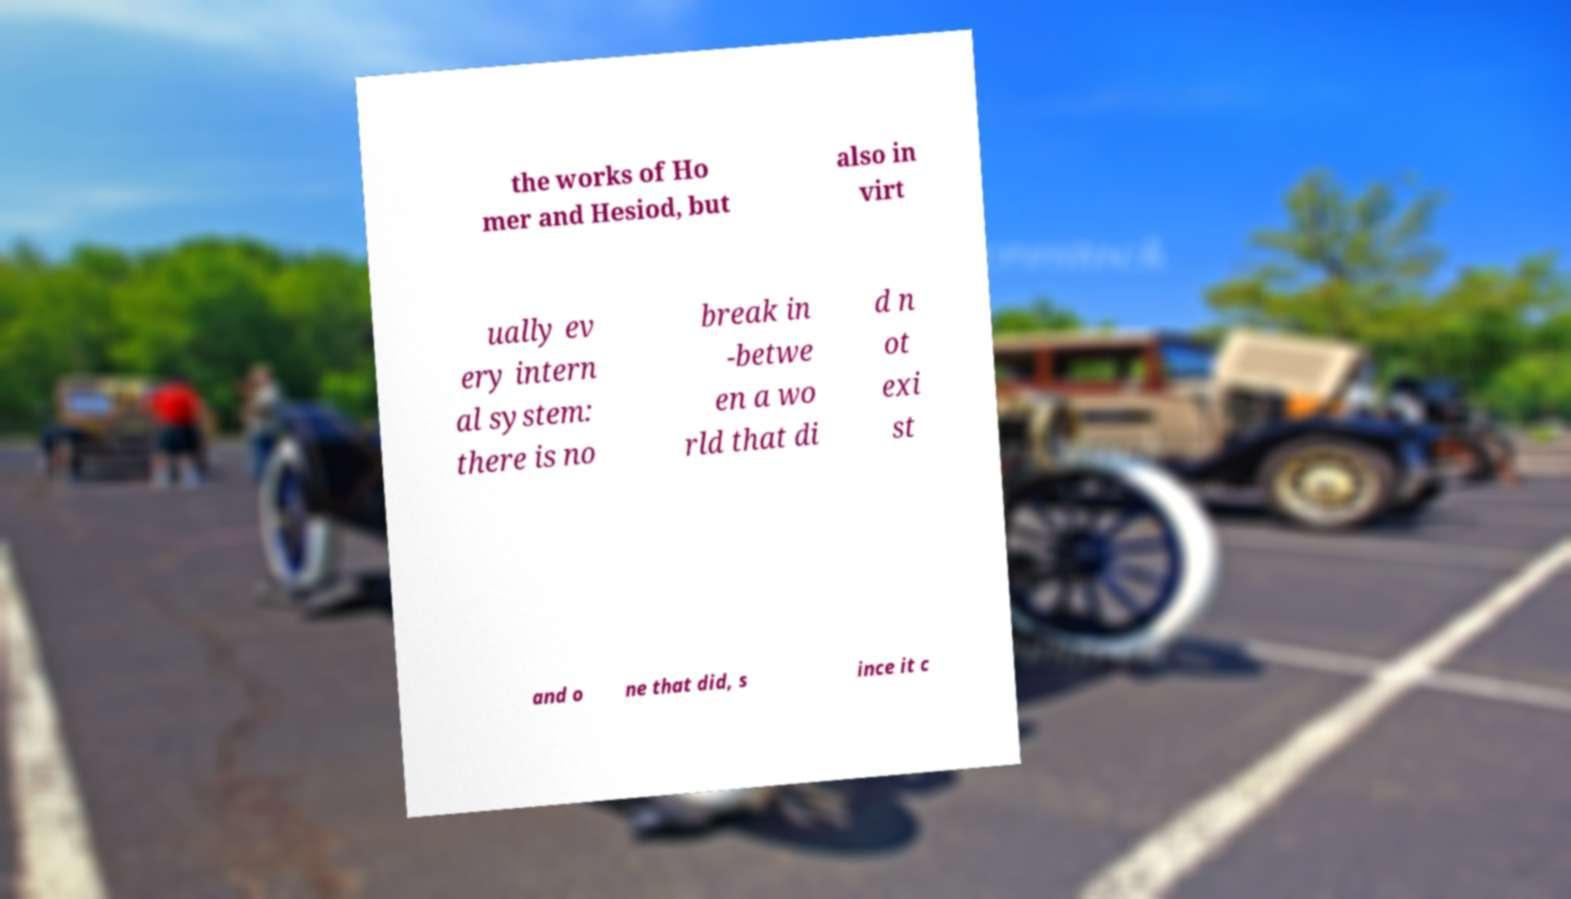I need the written content from this picture converted into text. Can you do that? the works of Ho mer and Hesiod, but also in virt ually ev ery intern al system: there is no break in -betwe en a wo rld that di d n ot exi st and o ne that did, s ince it c 